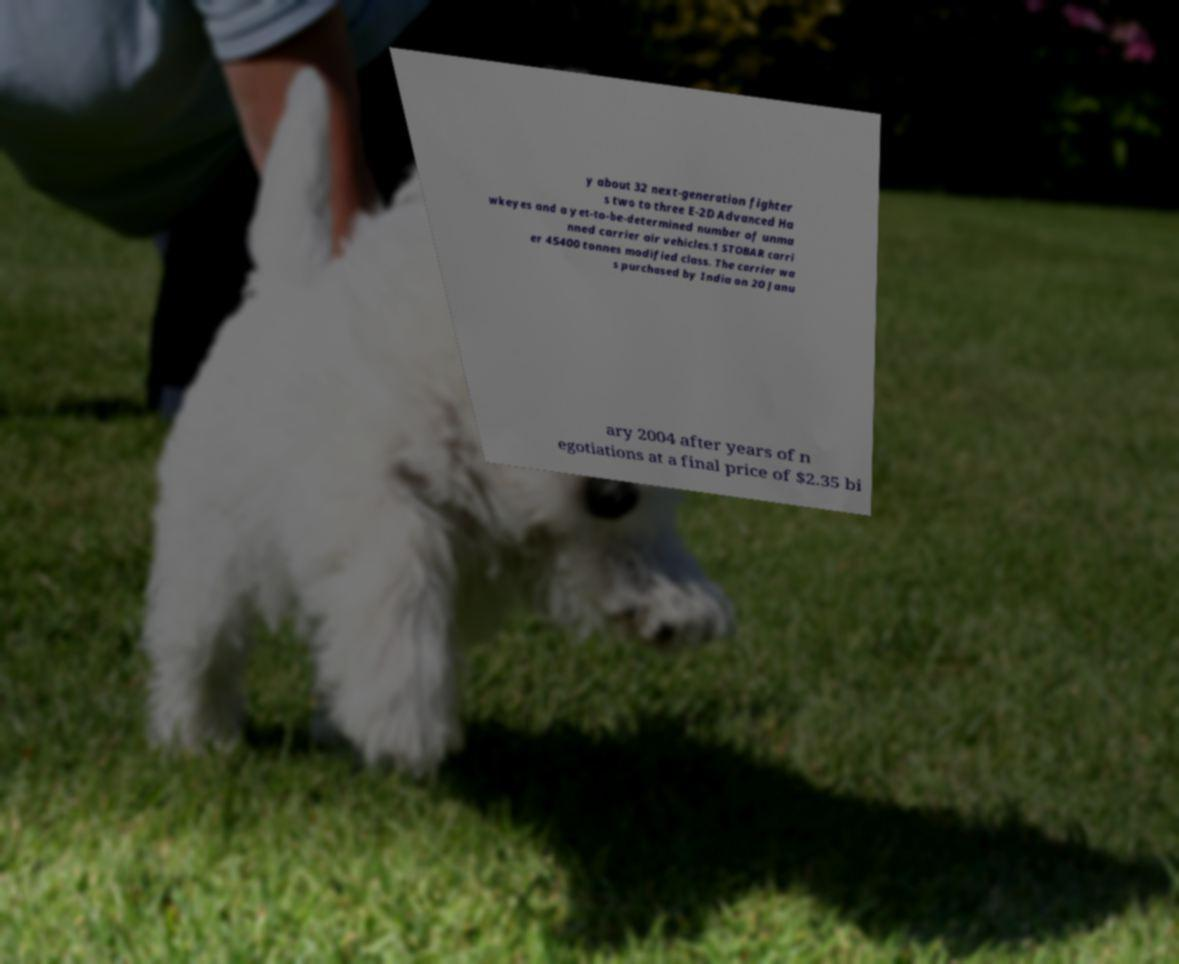I need the written content from this picture converted into text. Can you do that? y about 32 next-generation fighter s two to three E-2D Advanced Ha wkeyes and a yet-to-be-determined number of unma nned carrier air vehicles.1 STOBAR carri er 45400 tonnes modified class. The carrier wa s purchased by India on 20 Janu ary 2004 after years of n egotiations at a final price of $2.35 bi 